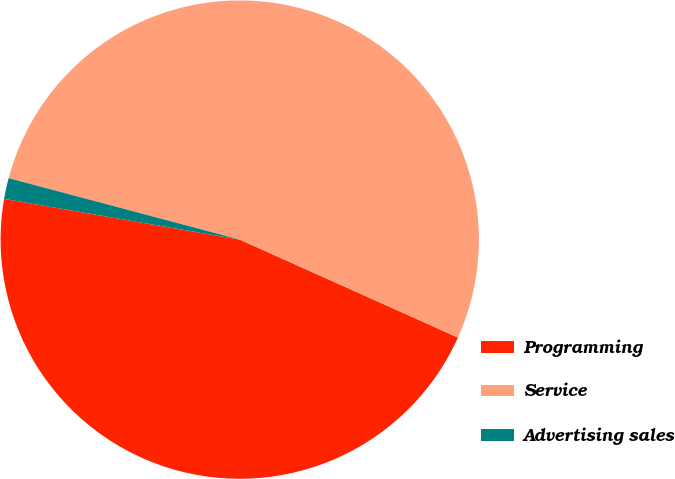Convert chart to OTSL. <chart><loc_0><loc_0><loc_500><loc_500><pie_chart><fcel>Programming<fcel>Service<fcel>Advertising sales<nl><fcel>46.01%<fcel>52.58%<fcel>1.41%<nl></chart> 